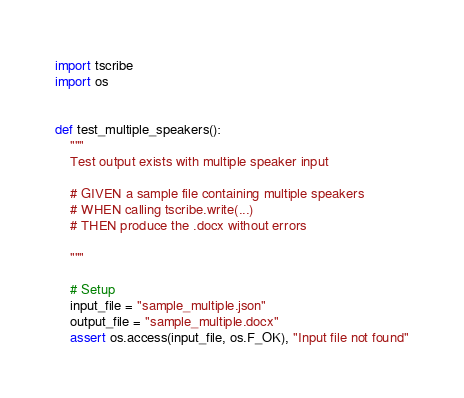<code> <loc_0><loc_0><loc_500><loc_500><_Python_>import tscribe
import os


def test_multiple_speakers():
    """
    Test output exists with multiple speaker input

    # GIVEN a sample file containing multiple speakers
    # WHEN calling tscribe.write(...)
    # THEN produce the .docx without errors

    """

    # Setup
    input_file = "sample_multiple.json"
    output_file = "sample_multiple.docx"
    assert os.access(input_file, os.F_OK), "Input file not found"
</code> 